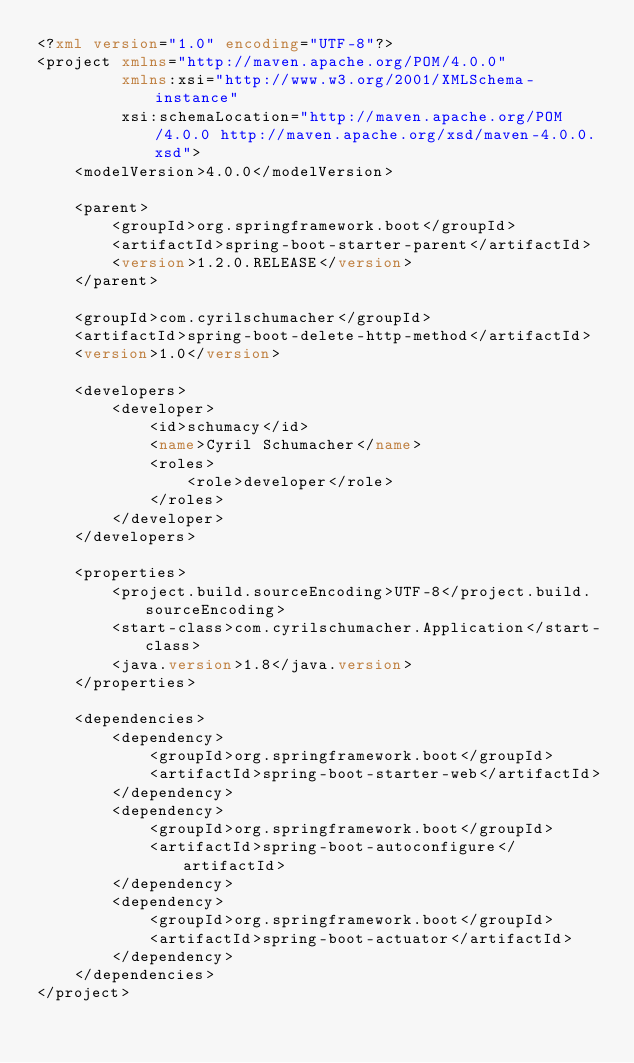Convert code to text. <code><loc_0><loc_0><loc_500><loc_500><_XML_><?xml version="1.0" encoding="UTF-8"?>
<project xmlns="http://maven.apache.org/POM/4.0.0"
         xmlns:xsi="http://www.w3.org/2001/XMLSchema-instance"
         xsi:schemaLocation="http://maven.apache.org/POM/4.0.0 http://maven.apache.org/xsd/maven-4.0.0.xsd">
    <modelVersion>4.0.0</modelVersion>

    <parent>
        <groupId>org.springframework.boot</groupId>
        <artifactId>spring-boot-starter-parent</artifactId>
        <version>1.2.0.RELEASE</version>
    </parent>

    <groupId>com.cyrilschumacher</groupId>
    <artifactId>spring-boot-delete-http-method</artifactId>
    <version>1.0</version>

    <developers>
        <developer>
            <id>schumacy</id>
            <name>Cyril Schumacher</name>
            <roles>
                <role>developer</role>
            </roles>
        </developer>
    </developers>

    <properties>
        <project.build.sourceEncoding>UTF-8</project.build.sourceEncoding>
        <start-class>com.cyrilschumacher.Application</start-class>
        <java.version>1.8</java.version>
    </properties>

    <dependencies>
        <dependency>
            <groupId>org.springframework.boot</groupId>
            <artifactId>spring-boot-starter-web</artifactId>
        </dependency>
        <dependency>
            <groupId>org.springframework.boot</groupId>
            <artifactId>spring-boot-autoconfigure</artifactId>
        </dependency>
        <dependency>
            <groupId>org.springframework.boot</groupId>
            <artifactId>spring-boot-actuator</artifactId>
        </dependency>
    </dependencies>
</project></code> 